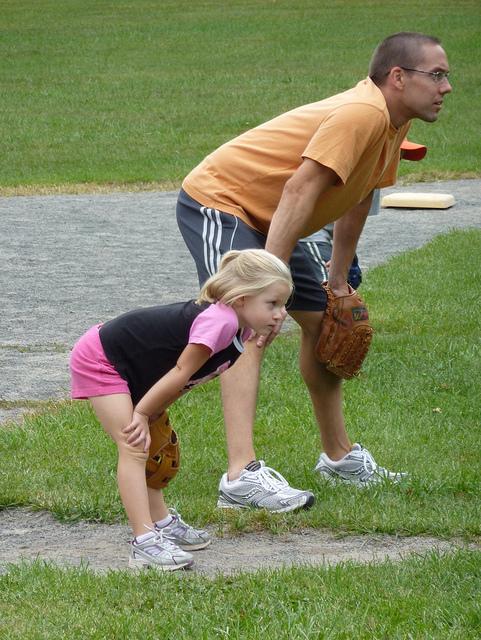Is this a family event?
Answer briefly. Yes. Are their shoes the same color?
Answer briefly. Yes. Are the two people the same gender?
Quick response, please. No. 